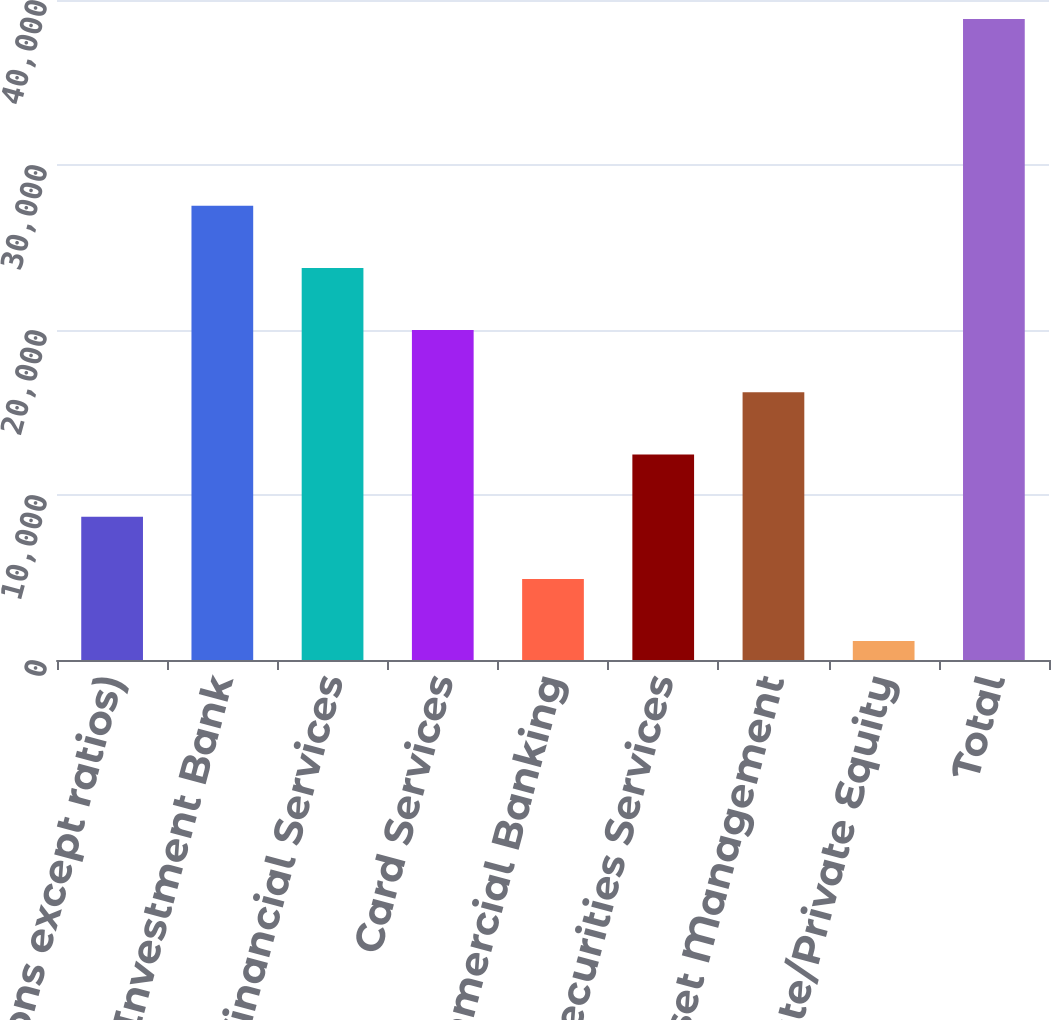<chart> <loc_0><loc_0><loc_500><loc_500><bar_chart><fcel>(in millions except ratios)<fcel>Investment Bank<fcel>Retail Financial Services<fcel>Card Services<fcel>Commercial Banking<fcel>Treasury & Securities Services<fcel>Asset Management<fcel>Corporate/Private Equity<fcel>Total<nl><fcel>8686.2<fcel>27534.2<fcel>23764.6<fcel>19995<fcel>4916.6<fcel>12455.8<fcel>16225.4<fcel>1147<fcel>38843<nl></chart> 